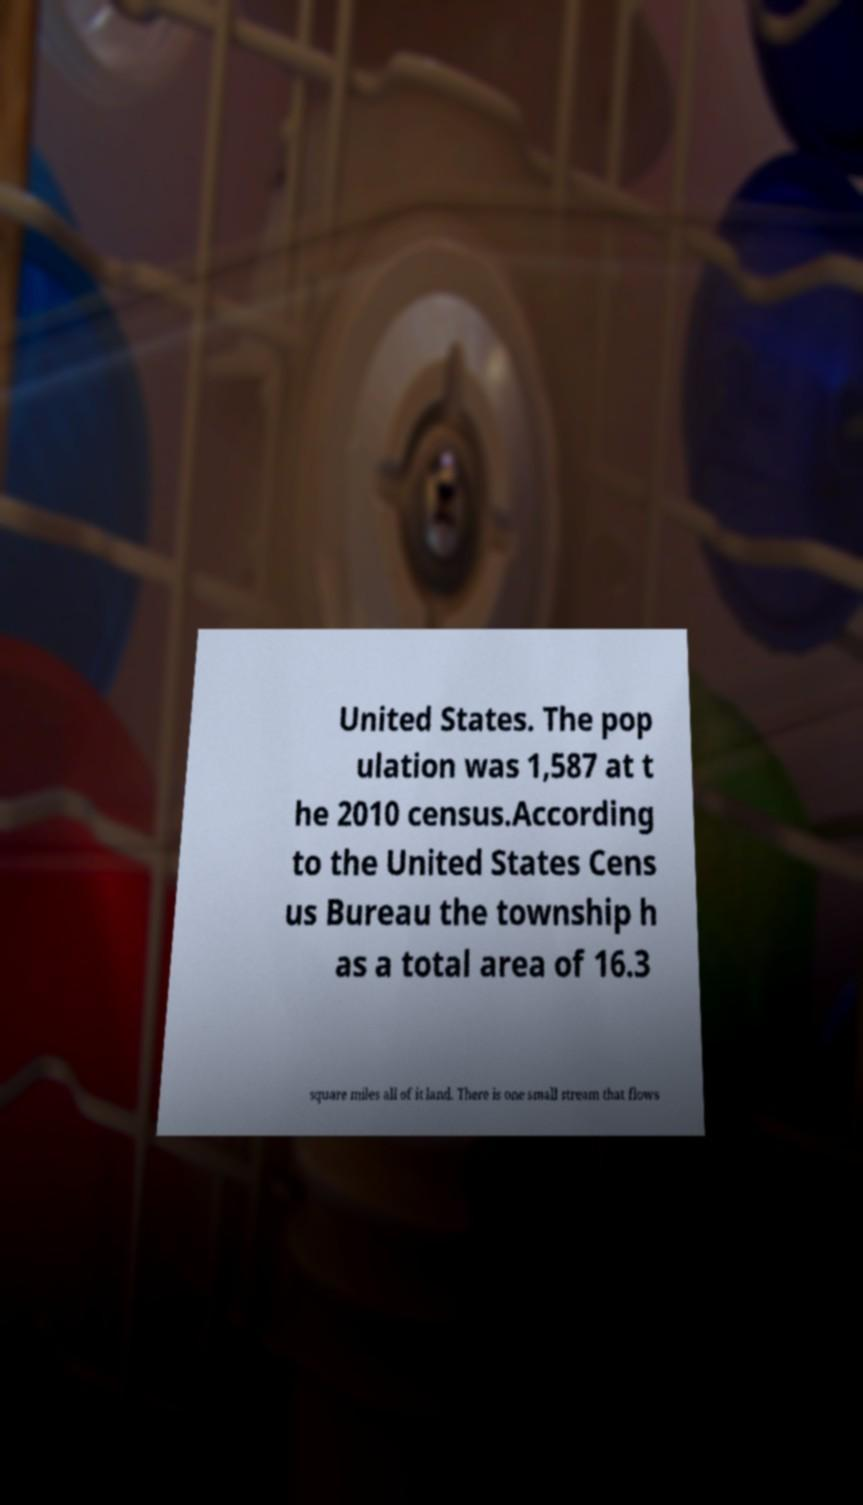There's text embedded in this image that I need extracted. Can you transcribe it verbatim? United States. The pop ulation was 1,587 at t he 2010 census.According to the United States Cens us Bureau the township h as a total area of 16.3 square miles all of it land. There is one small stream that flows 